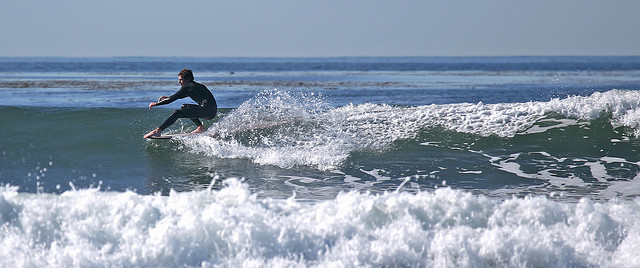<image>How cold is the water? It is ambiguous to determine how cold the water is. How cold is the water? I don't know how cold the water is. It can be either cold, freezing, warm or very cold. 